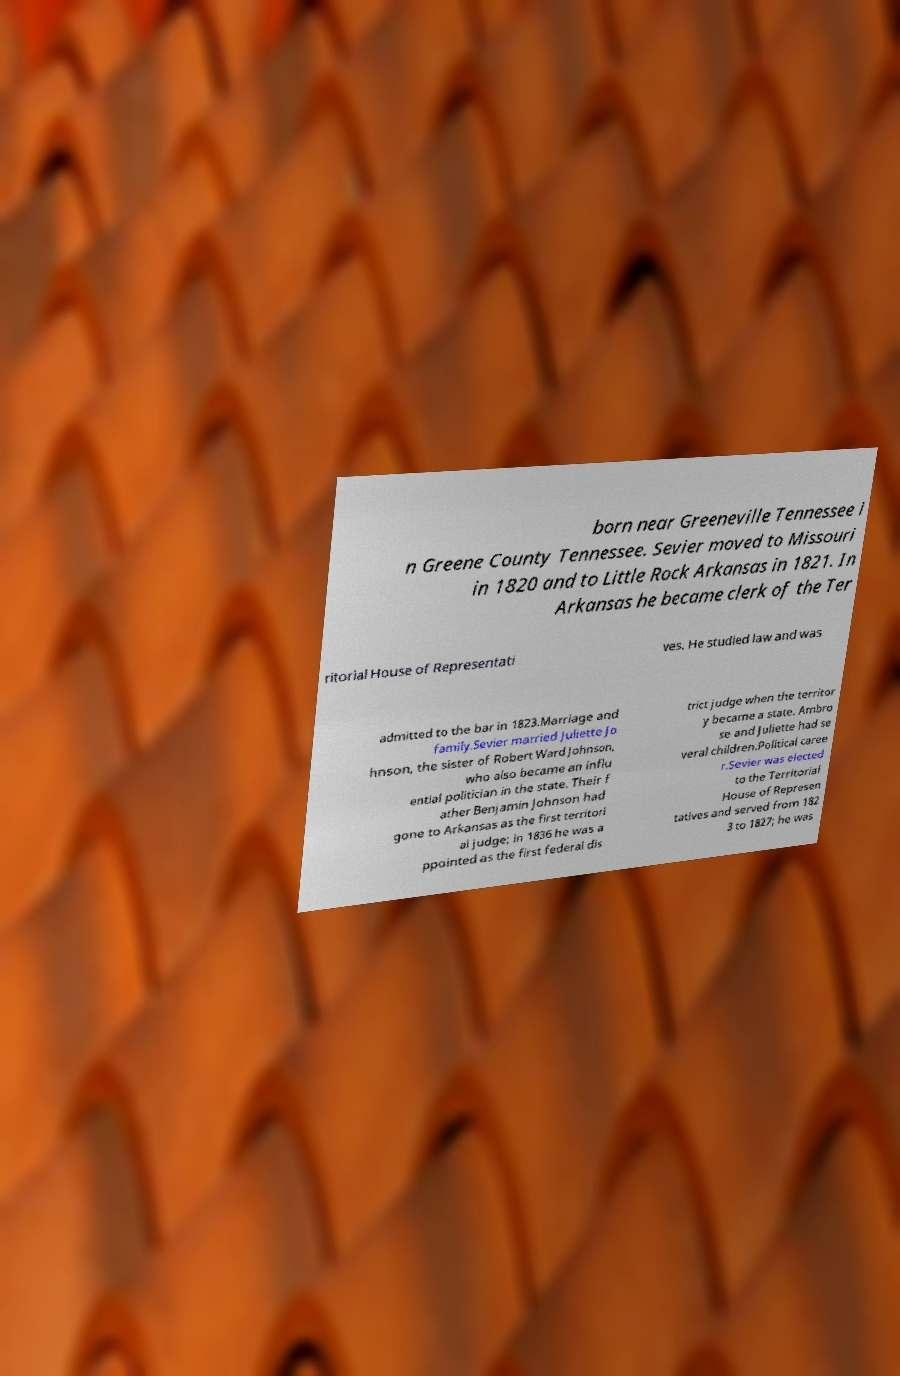What messages or text are displayed in this image? I need them in a readable, typed format. born near Greeneville Tennessee i n Greene County Tennessee. Sevier moved to Missouri in 1820 and to Little Rock Arkansas in 1821. In Arkansas he became clerk of the Ter ritorial House of Representati ves. He studied law and was admitted to the bar in 1823.Marriage and family.Sevier married Juliette Jo hnson, the sister of Robert Ward Johnson, who also became an influ ential politician in the state. Their f ather Benjamin Johnson had gone to Arkansas as the first territori al judge; in 1836 he was a ppointed as the first federal dis trict judge when the territor y became a state. Ambro se and Juliette had se veral children.Political caree r.Sevier was elected to the Territorial House of Represen tatives and served from 182 3 to 1827; he was 